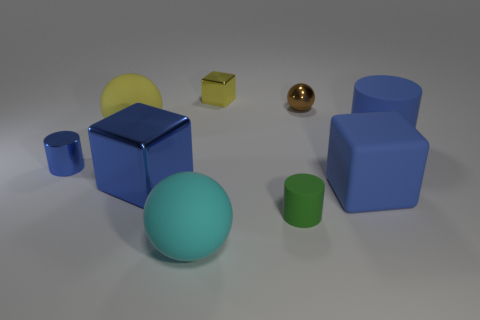Subtract all blue cylinders. How many were subtracted if there are1blue cylinders left? 1 Subtract all purple cylinders. Subtract all blue balls. How many cylinders are left? 3 Subtract all cylinders. How many objects are left? 6 Subtract all green objects. Subtract all small green rubber things. How many objects are left? 7 Add 9 blue metallic cylinders. How many blue metallic cylinders are left? 10 Add 8 tiny blue metal cylinders. How many tiny blue metal cylinders exist? 9 Subtract 0 purple balls. How many objects are left? 9 